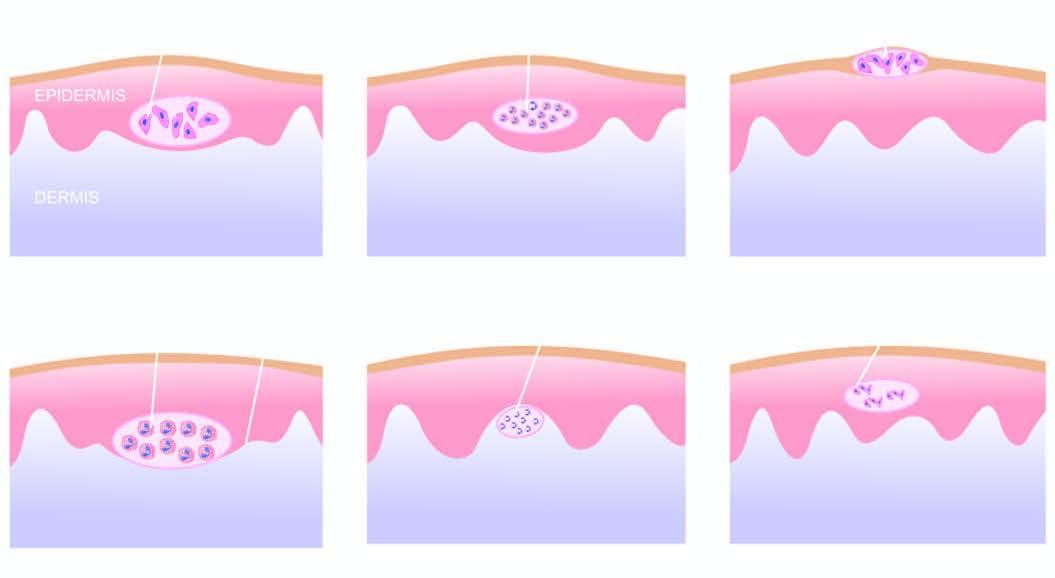s there a papillary microabscess composed of neutrophils?
Answer the question using a single word or phrase. Yes 